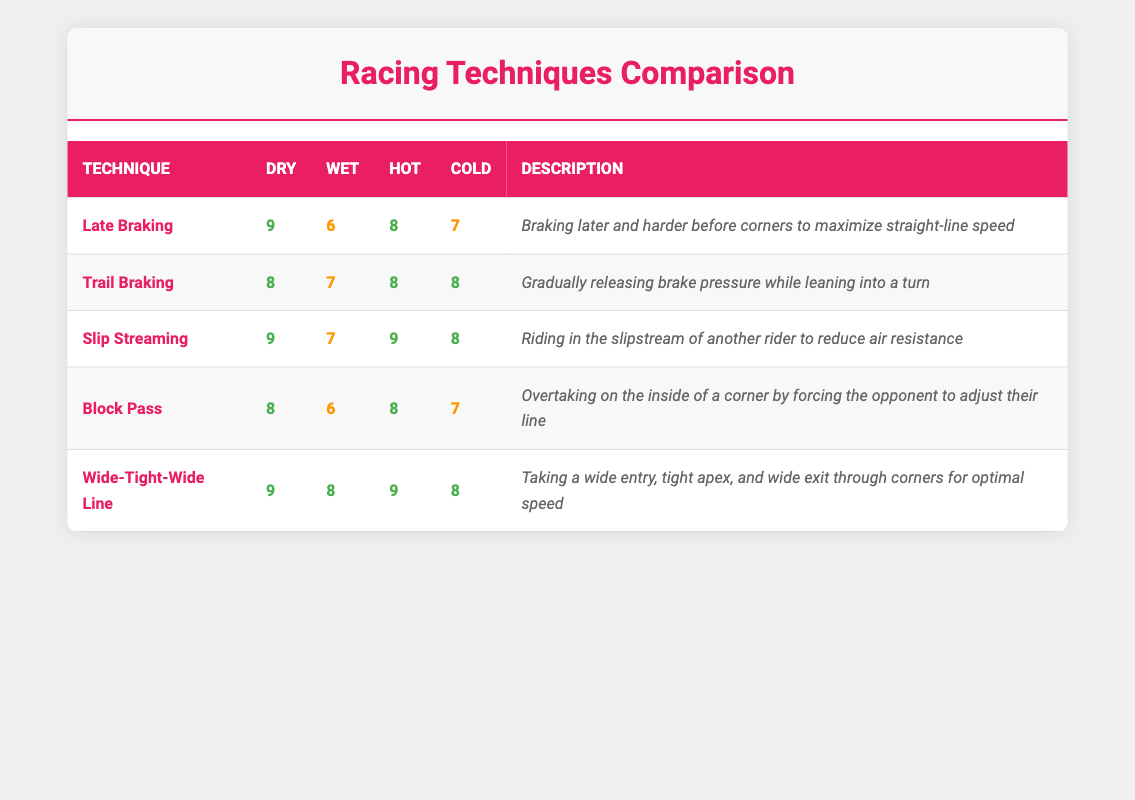What is the effectiveness of Late Braking in dry conditions? According to the table, the effectiveness of Late Braking in dry conditions is listed as 9.
Answer: 9 Which racing technique has the highest effectiveness in wet conditions? From the table, Slip Streaming and Wide-Tight-Wide Line both have the highest effectiveness in wet conditions, both rated at 8.
Answer: 8 Is Trail Braking equally effective in hot and cold conditions? By looking at the table, we see that Trail Braking has an effectiveness of 8 in both hot and cold conditions, indicating they are equally effective.
Answer: Yes What is the difference in effectiveness between Block Pass in dry and wet conditions? The table shows that Block Pass is rated 8 in dry conditions and 6 in wet conditions. The difference is 8 - 6 = 2.
Answer: 2 What is the average effectiveness of Slip Streaming across all weather conditions? To find the average, we sum the effectiveness values: 9 (Dry) + 7 (Wet) + 9 (Hot) + 8 (Cold) = 33. There are 4 conditions, so the average is 33 / 4 = 8.25.
Answer: 8.25 Which technique is the least effective in wet conditions, and what is its effectiveness score? In wet conditions, Late Braking has an effectiveness score of 6, which is the lowest among all techniques listed.
Answer: Late Braking, 6 Is Wide-Tight-Wide Line more effective than Block Pass in cold conditions? Wide-Tight-Wide Line has an effectiveness score of 8 in cold conditions, while Block Pass has a score of 7, indicating that Wide-Tight-Wide Line is more effective.
Answer: Yes How does the effectiveness of Slip Streaming compare in dry and hot conditions? The table indicates that Slip Streaming has an effectiveness of 9 in both dry and hot conditions; therefore, it is equally effective in both.
Answer: Equal What is the effectiveness score for Trail Braking in wet conditions compared to dry conditions? Trail Braking has an effectiveness of 7 in wet conditions and 8 in dry conditions, indicating it is less effective in wet conditions.
Answer: Less effective 